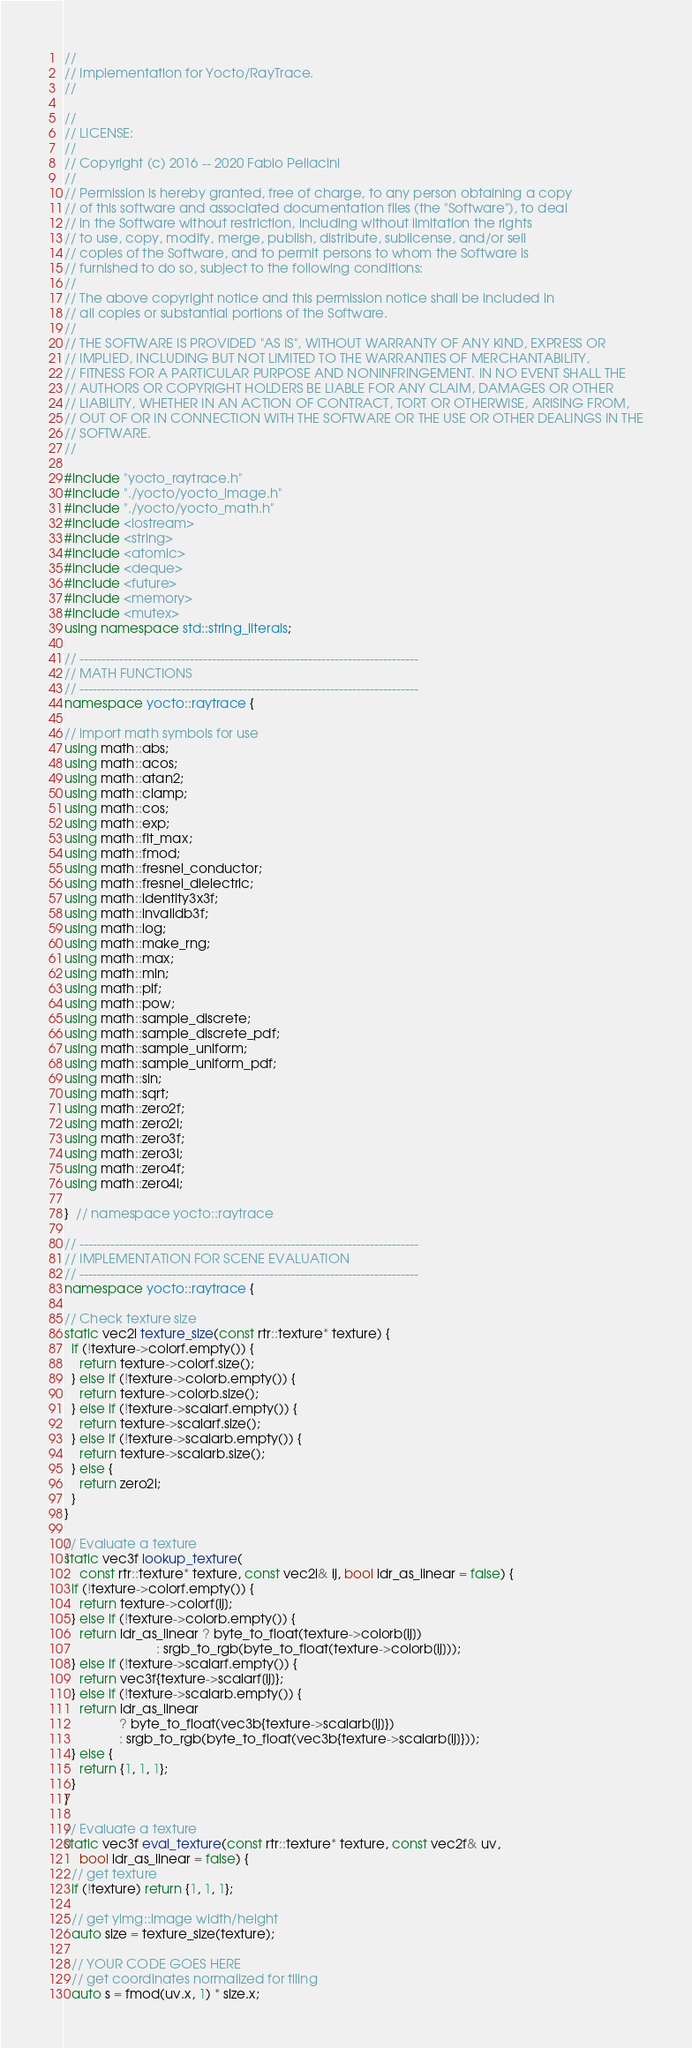Convert code to text. <code><loc_0><loc_0><loc_500><loc_500><_C++_>//
// Implementation for Yocto/RayTrace.
//

//
// LICENSE:
//
// Copyright (c) 2016 -- 2020 Fabio Pellacini
//
// Permission is hereby granted, free of charge, to any person obtaining a copy
// of this software and associated documentation files (the "Software"), to deal
// in the Software without restriction, including without limitation the rights
// to use, copy, modify, merge, publish, distribute, sublicense, and/or sell
// copies of the Software, and to permit persons to whom the Software is
// furnished to do so, subject to the following conditions:
//
// The above copyright notice and this permission notice shall be included in
// all copies or substantial portions of the Software.
//
// THE SOFTWARE IS PROVIDED "AS IS", WITHOUT WARRANTY OF ANY KIND, EXPRESS OR
// IMPLIED, INCLUDING BUT NOT LIMITED TO THE WARRANTIES OF MERCHANTABILITY,
// FITNESS FOR A PARTICULAR PURPOSE AND NONINFRINGEMENT. IN NO EVENT SHALL THE
// AUTHORS OR COPYRIGHT HOLDERS BE LIABLE FOR ANY CLAIM, DAMAGES OR OTHER
// LIABILITY, WHETHER IN AN ACTION OF CONTRACT, TORT OR OTHERWISE, ARISING FROM,
// OUT OF OR IN CONNECTION WITH THE SOFTWARE OR THE USE OR OTHER DEALINGS IN THE
// SOFTWARE.
//

#include "yocto_raytrace.h"
#include "./yocto/yocto_image.h"
#include "./yocto/yocto_math.h"
#include <iostream>
#include <string>
#include <atomic>
#include <deque>
#include <future>
#include <memory>
#include <mutex>
using namespace std::string_literals;

// -----------------------------------------------------------------------------
// MATH FUNCTIONS
// -----------------------------------------------------------------------------
namespace yocto::raytrace {

// import math symbols for use
using math::abs;
using math::acos;
using math::atan2;
using math::clamp;
using math::cos;
using math::exp;
using math::flt_max;
using math::fmod;
using math::fresnel_conductor;
using math::fresnel_dielectric;
using math::identity3x3f;
using math::invalidb3f;
using math::log;
using math::make_rng;
using math::max;
using math::min;
using math::pif;
using math::pow;
using math::sample_discrete;
using math::sample_discrete_pdf;
using math::sample_uniform;
using math::sample_uniform_pdf;
using math::sin;
using math::sqrt;
using math::zero2f;
using math::zero2i;
using math::zero3f;
using math::zero3i;
using math::zero4f;
using math::zero4i;

}  // namespace yocto::raytrace

// -----------------------------------------------------------------------------
// IMPLEMENTATION FOR SCENE EVALUATION
// -----------------------------------------------------------------------------
namespace yocto::raytrace {

// Check texture size
static vec2i texture_size(const rtr::texture* texture) {
  if (!texture->colorf.empty()) {
    return texture->colorf.size();
  } else if (!texture->colorb.empty()) {
    return texture->colorb.size();
  } else if (!texture->scalarf.empty()) {
    return texture->scalarf.size();
  } else if (!texture->scalarb.empty()) {
    return texture->scalarb.size();
  } else {
    return zero2i;
  }
}

// Evaluate a texture
static vec3f lookup_texture(
    const rtr::texture* texture, const vec2i& ij, bool ldr_as_linear = false) {
  if (!texture->colorf.empty()) {
    return texture->colorf[ij];
  } else if (!texture->colorb.empty()) {
    return ldr_as_linear ? byte_to_float(texture->colorb[ij])
                         : srgb_to_rgb(byte_to_float(texture->colorb[ij]));
  } else if (!texture->scalarf.empty()) {
    return vec3f{texture->scalarf[ij]};
  } else if (!texture->scalarb.empty()) {
    return ldr_as_linear
               ? byte_to_float(vec3b{texture->scalarb[ij]})
               : srgb_to_rgb(byte_to_float(vec3b{texture->scalarb[ij]}));
  } else {
    return {1, 1, 1};
  }
}

// Evaluate a texture
static vec3f eval_texture(const rtr::texture* texture, const vec2f& uv,
    bool ldr_as_linear = false) {
  // get texture
  if (!texture) return {1, 1, 1};

  // get yimg::image width/height
  auto size = texture_size(texture);

  // YOUR CODE GOES HERE
  // get coordinates normalized for tiling
  auto s = fmod(uv.x, 1) * size.x;</code> 